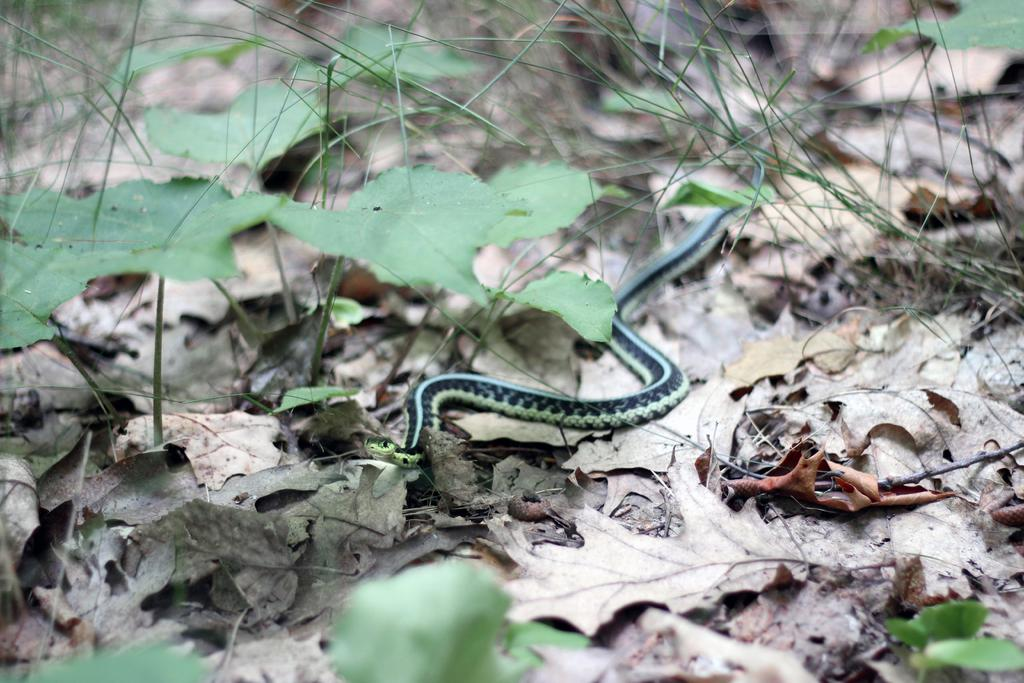What is the main subject in the center of the image? There is a snake in the center of the image. What type of vegetation can be seen in the image? There is grass and other plants in the image. What can be found on the ground in the image? Dried leaves are present on the ground in the image. What time of day is it in the image, and how hot is it? The time of day and temperature are not mentioned in the image, so we cannot determine if it is hot or what time of day it is. 